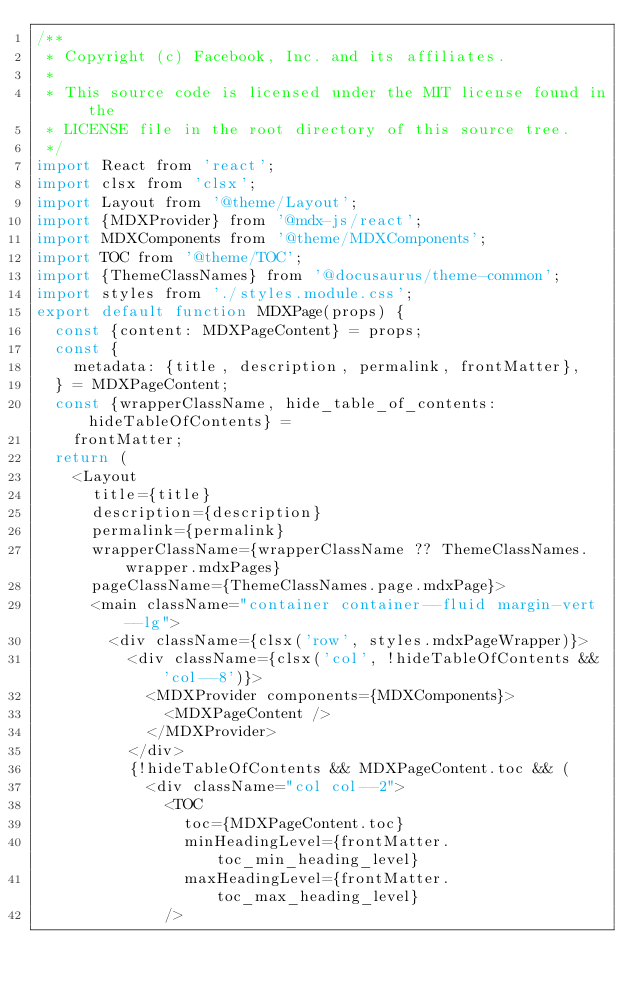<code> <loc_0><loc_0><loc_500><loc_500><_JavaScript_>/**
 * Copyright (c) Facebook, Inc. and its affiliates.
 *
 * This source code is licensed under the MIT license found in the
 * LICENSE file in the root directory of this source tree.
 */
import React from 'react';
import clsx from 'clsx';
import Layout from '@theme/Layout';
import {MDXProvider} from '@mdx-js/react';
import MDXComponents from '@theme/MDXComponents';
import TOC from '@theme/TOC';
import {ThemeClassNames} from '@docusaurus/theme-common';
import styles from './styles.module.css';
export default function MDXPage(props) {
  const {content: MDXPageContent} = props;
  const {
    metadata: {title, description, permalink, frontMatter},
  } = MDXPageContent;
  const {wrapperClassName, hide_table_of_contents: hideTableOfContents} =
    frontMatter;
  return (
    <Layout
      title={title}
      description={description}
      permalink={permalink}
      wrapperClassName={wrapperClassName ?? ThemeClassNames.wrapper.mdxPages}
      pageClassName={ThemeClassNames.page.mdxPage}>
      <main className="container container--fluid margin-vert--lg">
        <div className={clsx('row', styles.mdxPageWrapper)}>
          <div className={clsx('col', !hideTableOfContents && 'col--8')}>
            <MDXProvider components={MDXComponents}>
              <MDXPageContent />
            </MDXProvider>
          </div>
          {!hideTableOfContents && MDXPageContent.toc && (
            <div className="col col--2">
              <TOC
                toc={MDXPageContent.toc}
                minHeadingLevel={frontMatter.toc_min_heading_level}
                maxHeadingLevel={frontMatter.toc_max_heading_level}
              /></code> 